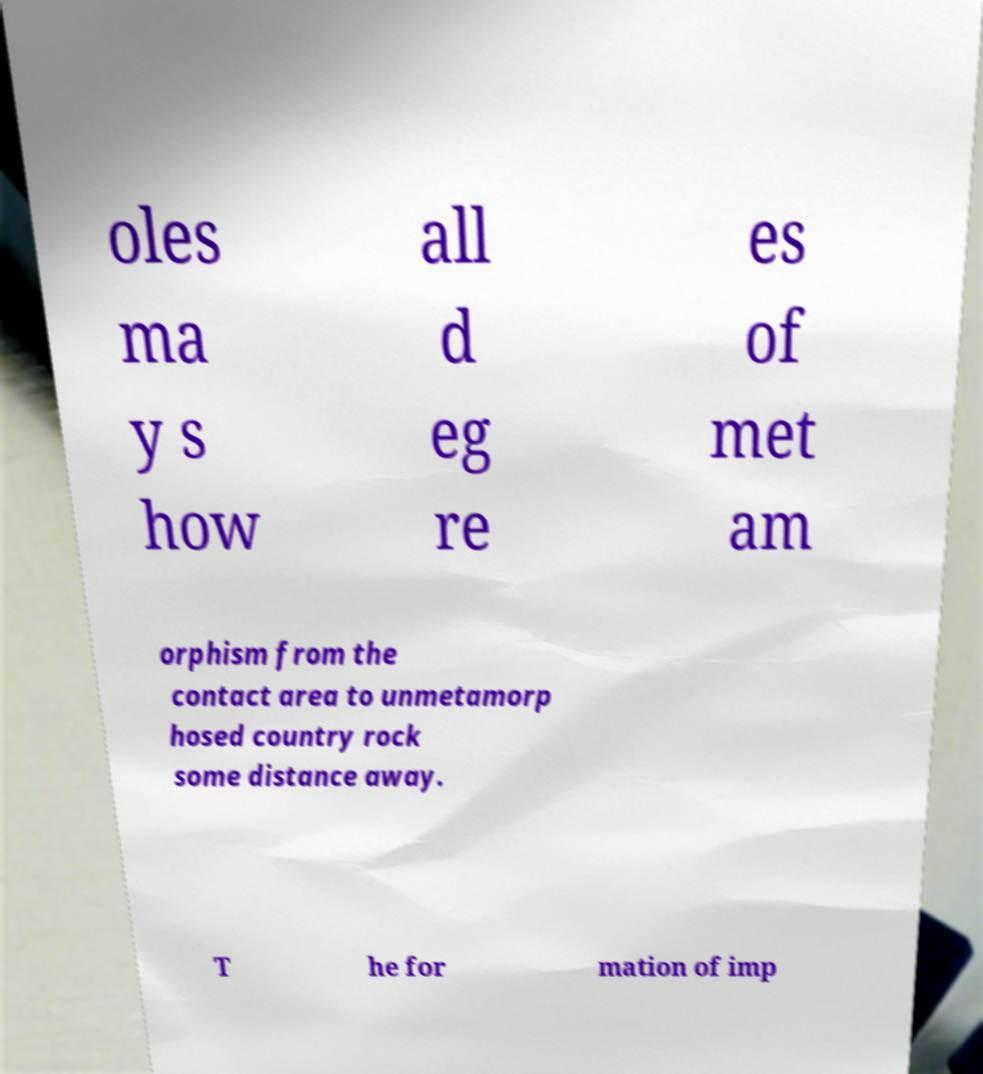Can you accurately transcribe the text from the provided image for me? oles ma y s how all d eg re es of met am orphism from the contact area to unmetamorp hosed country rock some distance away. T he for mation of imp 